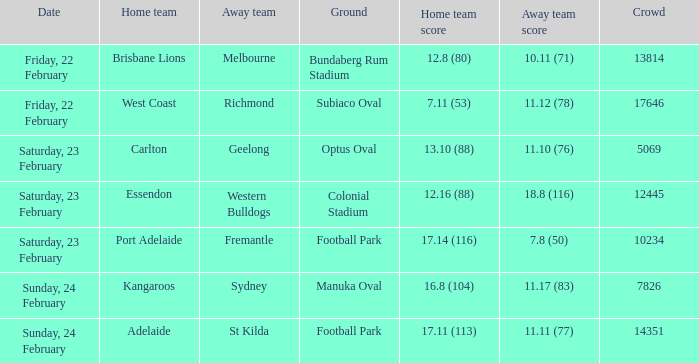On what date did the away team Fremantle play? Saturday, 23 February. 